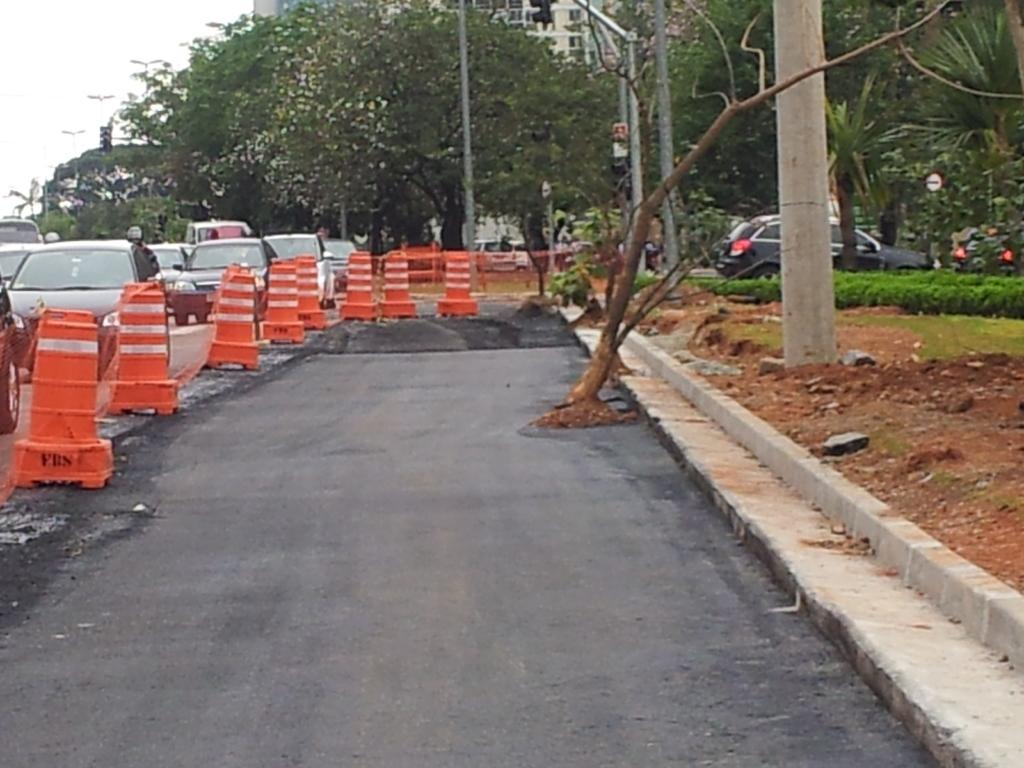What is blocking the road in the vehicles in the image? There are barricades on the road in the image. What types of vehicles can be seen on the road? There are vehicles on the road in the image. What structures are present in the image? There are poles, traffic lights, and barricades in the image. What type of vegetation is visible in the image? There are plants and trees in the image. What can be seen in the background of the image? The sky is visible in the background of the image. Where is the map located in the image? There is no map present in the image. What is in the pocket of the person in the image? There is no person or pocket visible in the image. 